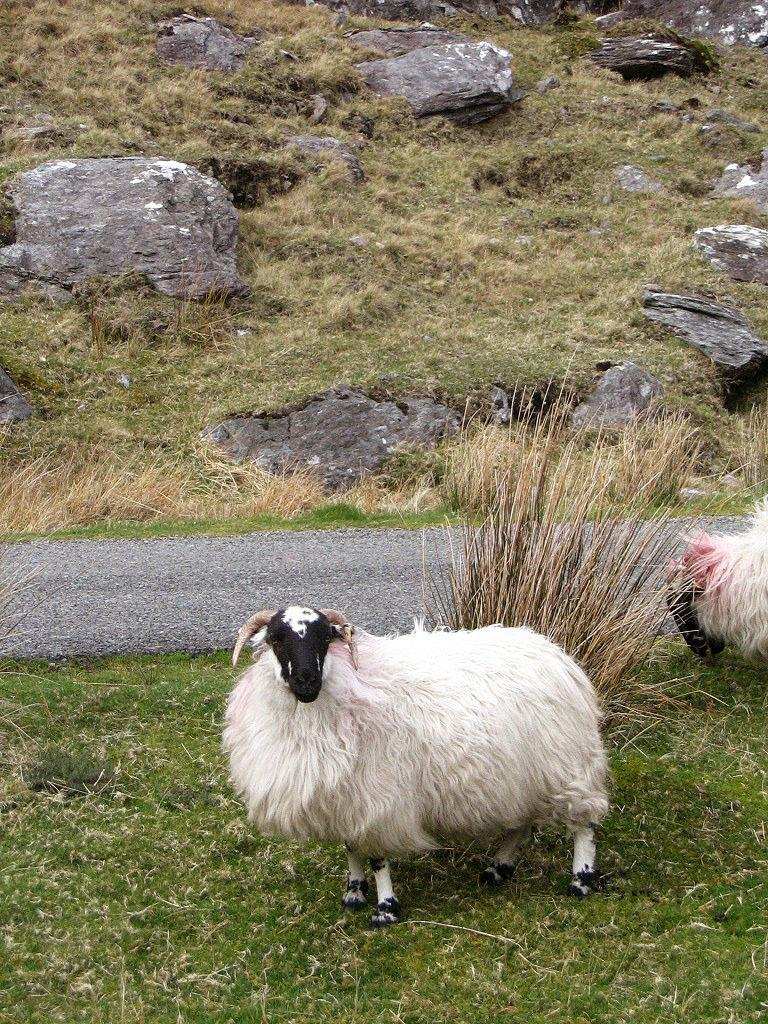What type of vegetation is present in the image? There is grass in the image. What other objects can be seen in the image? There are rocks in the image. What animals are visible in the image? There are white color sheep in the image. What part of the sheep is being judged in the image? There is no scene of judging in the image; it simply shows white sheep in a grassy area with rocks. 